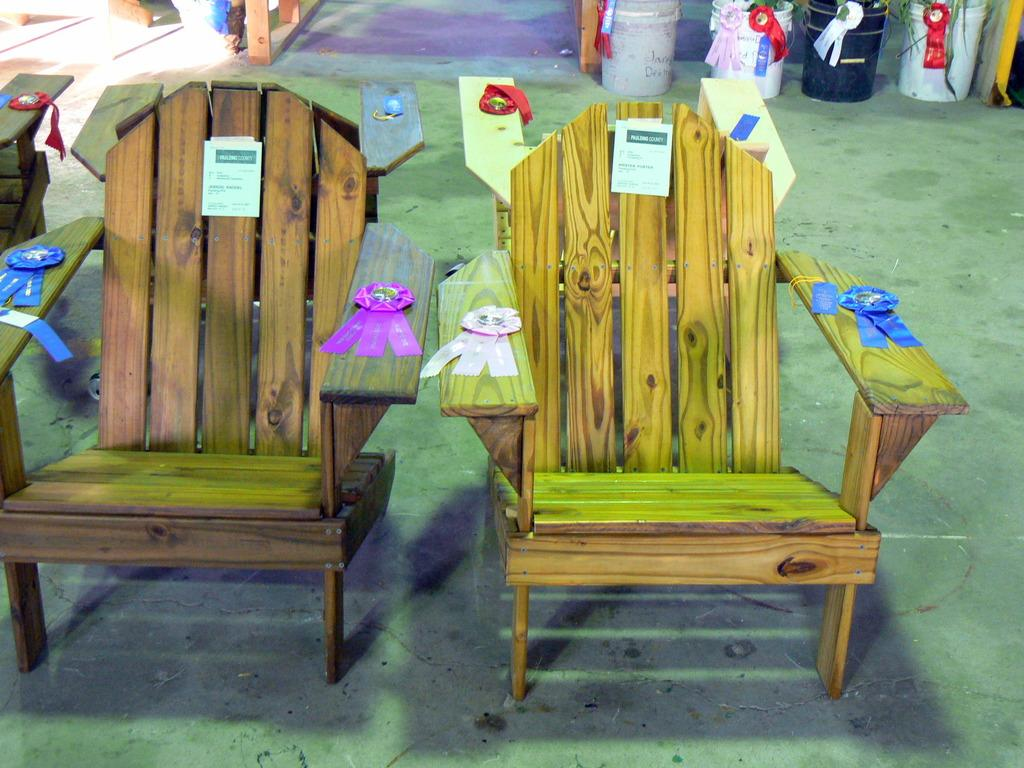What type of chairs are in the image? There are wooden chairs in the image. What is placed on the wooden chairs? There are objects on the wooden chairs. Can you describe any other objects visible in the image? There are other objects visible in the background of the image. Are there any objects on the floor in the image? Yes, some of these objects are on the floor. What is the kitty's belief about the objects on the wooden chairs? There is no kitty present in the image, so it is not possible to determine its beliefs about the objects on the wooden chairs. 